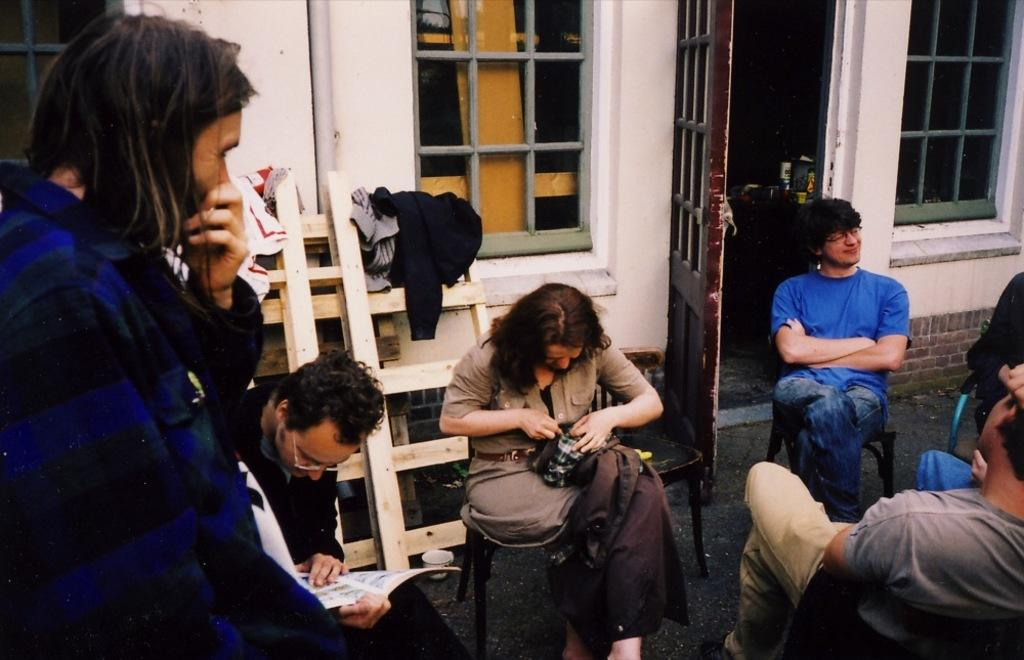What is the position of the person in the image? There is a person standing on the left side of the image. What are the other people in the image doing? There are people sitting in the image. What can be seen in the image besides the people? There is a wooden frame in the image. What is visible in the background of the image? There is a building in the background of the image. What features does the building have? The building has windows and a door that is open. What type of metal is the writer using to create the box in the image? There is no writer or box present in the image. 